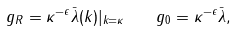<formula> <loc_0><loc_0><loc_500><loc_500>g _ { R } = \kappa ^ { - \epsilon } \bar { \lambda } ( k ) | _ { k = \kappa } \quad g _ { 0 } = \kappa ^ { - \epsilon } \bar { \lambda } ,</formula> 